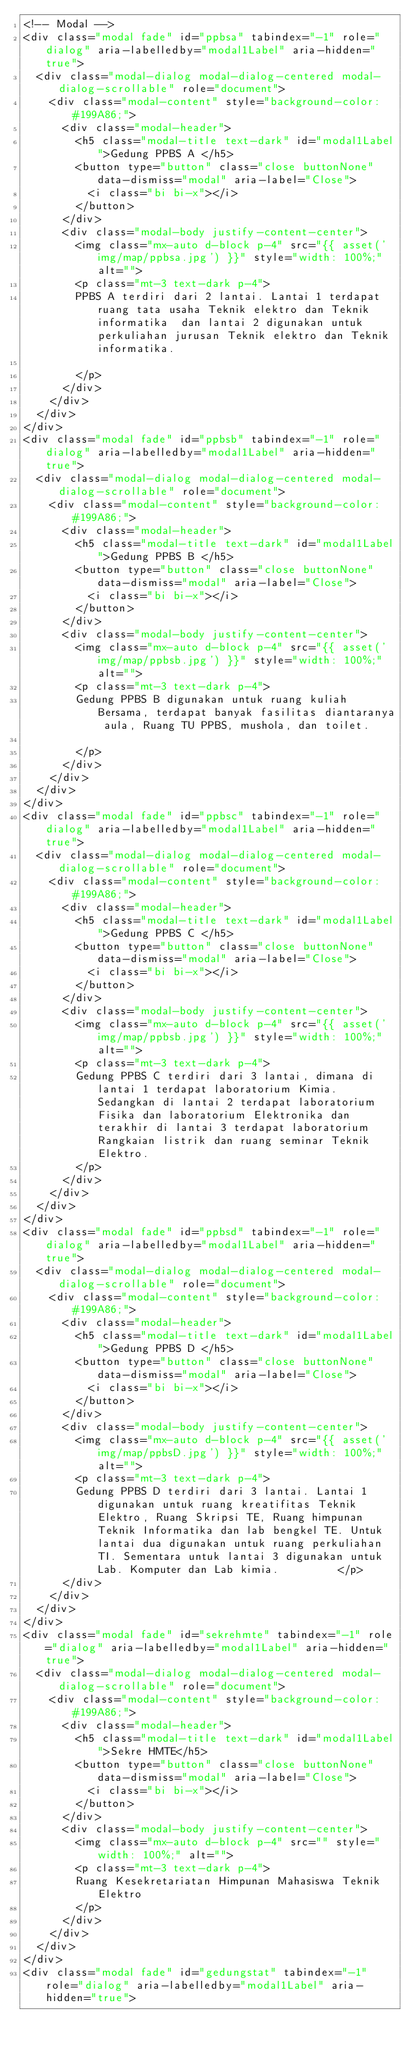<code> <loc_0><loc_0><loc_500><loc_500><_PHP_><!-- Modal -->
<div class="modal fade" id="ppbsa" tabindex="-1" role="dialog" aria-labelledby="modal1Label" aria-hidden="true">
  <div class="modal-dialog modal-dialog-centered modal-dialog-scrollable" role="document">
    <div class="modal-content" style="background-color: #199A86;">
      <div class="modal-header">
        <h5 class="modal-title text-dark" id="modal1Label">Gedung PPBS A </h5>
        <button type="button" class="close buttonNone" data-dismiss="modal" aria-label="Close">
          <i class="bi bi-x"></i>
        </button>
      </div>
      <div class="modal-body justify-content-center">
        <img class="mx-auto d-block p-4" src="{{ asset('img/map/ppbsa.jpg') }}" style="width: 100%;" alt="">
        <p class="mt-3 text-dark p-4">
        PPBS A terdiri dari 2 lantai. Lantai 1 terdapat ruang tata usaha Teknik elektro dan Teknik informatika  dan lantai 2 digunakan untuk perkuliahan jurusan Teknik elektro dan Teknik informatika.

        </p>
      </div>
    </div>
  </div>
</div>
<div class="modal fade" id="ppbsb" tabindex="-1" role="dialog" aria-labelledby="modal1Label" aria-hidden="true">
  <div class="modal-dialog modal-dialog-centered modal-dialog-scrollable" role="document">
    <div class="modal-content" style="background-color: #199A86;">
      <div class="modal-header">
        <h5 class="modal-title text-dark" id="modal1Label">Gedung PPBS B </h5>
        <button type="button" class="close buttonNone" data-dismiss="modal" aria-label="Close">
          <i class="bi bi-x"></i>
        </button>
      </div>
      <div class="modal-body justify-content-center">
        <img class="mx-auto d-block p-4" src="{{ asset('img/map/ppbsb.jpg') }}" style="width: 100%;" alt="">
        <p class="mt-3 text-dark p-4">
        Gedung PPBS B digunakan untuk ruang kuliah Bersama, terdapat banyak fasilitas diantaranya aula, Ruang TU PPBS, mushola, dan toilet.

        </p>
      </div>
    </div>
  </div>
</div>
<div class="modal fade" id="ppbsc" tabindex="-1" role="dialog" aria-labelledby="modal1Label" aria-hidden="true">
  <div class="modal-dialog modal-dialog-centered modal-dialog-scrollable" role="document">
    <div class="modal-content" style="background-color: #199A86;">
      <div class="modal-header">
        <h5 class="modal-title text-dark" id="modal1Label">Gedung PPBS C </h5>
        <button type="button" class="close buttonNone" data-dismiss="modal" aria-label="Close">
          <i class="bi bi-x"></i>
        </button>
      </div>
      <div class="modal-body justify-content-center">
        <img class="mx-auto d-block p-4" src="{{ asset('img/map/ppbsb.jpg') }}" style="width: 100%;" alt="">
        <p class="mt-3 text-dark p-4">
        Gedung PPBS C terdiri dari 3 lantai, dimana di lantai 1 terdapat laboratorium Kimia. Sedangkan di lantai 2 terdapat laboratorium Fisika dan laboratorium Elektronika dan terakhir di lantai 3 terdapat laboratorium Rangkaian listrik dan ruang seminar Teknik Elektro.
        </p>
      </div>
    </div>
  </div>
</div>
<div class="modal fade" id="ppbsd" tabindex="-1" role="dialog" aria-labelledby="modal1Label" aria-hidden="true">
  <div class="modal-dialog modal-dialog-centered modal-dialog-scrollable" role="document">
    <div class="modal-content" style="background-color: #199A86;">
      <div class="modal-header">
        <h5 class="modal-title text-dark" id="modal1Label">Gedung PPBS D </h5>
        <button type="button" class="close buttonNone" data-dismiss="modal" aria-label="Close">
          <i class="bi bi-x"></i>
        </button>
      </div>
      <div class="modal-body justify-content-center">
        <img class="mx-auto d-block p-4" src="{{ asset('img/map/ppbsD.jpg') }}" style="width: 100%;" alt="">
        <p class="mt-3 text-dark p-4">
        Gedung PPBS D terdiri dari 3 lantai. Lantai 1 digunakan untuk ruang kreatifitas Teknik Elektro, Ruang Skripsi TE, Ruang himpunan Teknik Informatika dan lab bengkel TE. Untuk lantai dua digunakan untuk ruang perkuliahan TI. Sementara untuk lantai 3 digunakan untuk Lab. Komputer dan Lab kimia.         </p>
      </div>
    </div>
  </div>
</div>
<div class="modal fade" id="sekrehmte" tabindex="-1" role="dialog" aria-labelledby="modal1Label" aria-hidden="true">
  <div class="modal-dialog modal-dialog-centered modal-dialog-scrollable" role="document">
    <div class="modal-content" style="background-color: #199A86;">
      <div class="modal-header">
        <h5 class="modal-title text-dark" id="modal1Label">Sekre HMTE</h5>
        <button type="button" class="close buttonNone" data-dismiss="modal" aria-label="Close">
          <i class="bi bi-x"></i>
        </button>
      </div>
      <div class="modal-body justify-content-center">
        <img class="mx-auto d-block p-4" src="" style="width: 100%;" alt="">
        <p class="mt-3 text-dark p-4">
        Ruang Kesekretariatan Himpunan Mahasiswa Teknik Elektro
        </p>
      </div>
    </div>
  </div>
</div>
<div class="modal fade" id="gedungstat" tabindex="-1" role="dialog" aria-labelledby="modal1Label" aria-hidden="true"></code> 